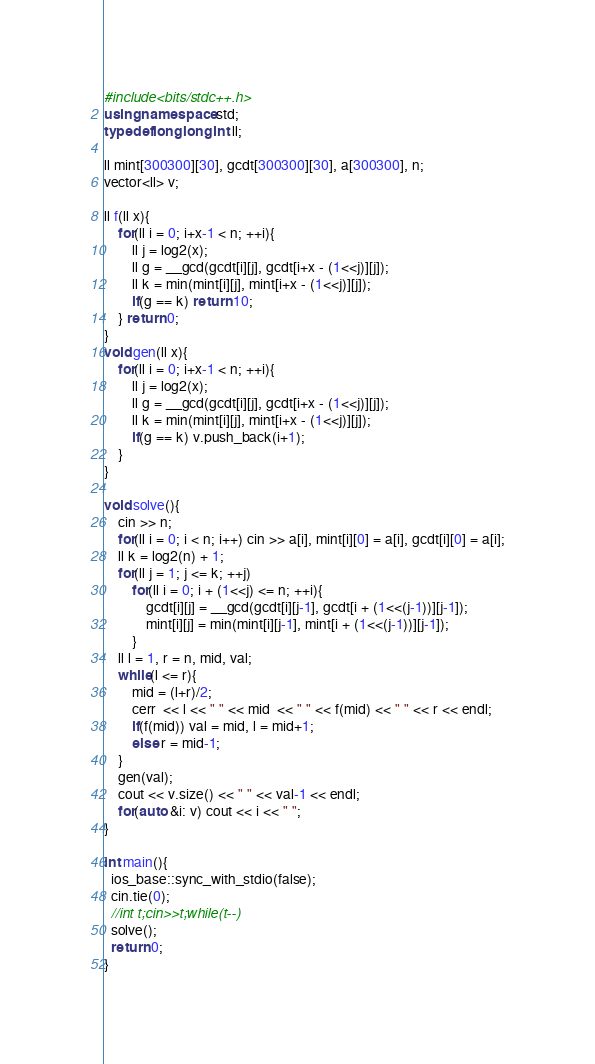<code> <loc_0><loc_0><loc_500><loc_500><_C++_>#include<bits/stdc++.h>
using namespace std;
typedef long long int ll;

ll mint[300300][30], gcdt[300300][30], a[300300], n;
vector<ll> v;

ll f(ll x){
    for(ll i = 0; i+x-1 < n; ++i){
        ll j = log2(x);
        ll g = __gcd(gcdt[i][j], gcdt[i+x - (1<<j)][j]);
        ll k = min(mint[i][j], mint[i+x - (1<<j)][j]);
        if(g == k) return 10;
    } return 0;
}
void gen(ll x){
    for(ll i = 0; i+x-1 < n; ++i){
        ll j = log2(x);
        ll g = __gcd(gcdt[i][j], gcdt[i+x - (1<<j)][j]);
        ll k = min(mint[i][j], mint[i+x - (1<<j)][j]);
        if(g == k) v.push_back(i+1);
    }
}

void solve(){
    cin >> n;
    for(ll i = 0; i < n; i++) cin >> a[i], mint[i][0] = a[i], gcdt[i][0] = a[i];
    ll k = log2(n) + 1;
    for(ll j = 1; j <= k; ++j)
        for(ll i = 0; i + (1<<j) <= n; ++i){
            gcdt[i][j] = __gcd(gcdt[i][j-1], gcdt[i + (1<<(j-1))][j-1]);
            mint[i][j] = min(mint[i][j-1], mint[i + (1<<(j-1))][j-1]);
        }
    ll l = 1, r = n, mid, val;
    while(l <= r){
        mid = (l+r)/2;
        cerr  << l << " " << mid  << " " << f(mid) << " " << r << endl;
        if(f(mid)) val = mid, l = mid+1;
        else r = mid-1;
    }
    gen(val);
    cout << v.size() << " " << val-1 << endl;
    for(auto &i: v) cout << i << " ";
}

int main(){
  ios_base::sync_with_stdio(false);
  cin.tie(0);
  //int t;cin>>t;while(t--)
  solve();
  return 0;
}
</code> 